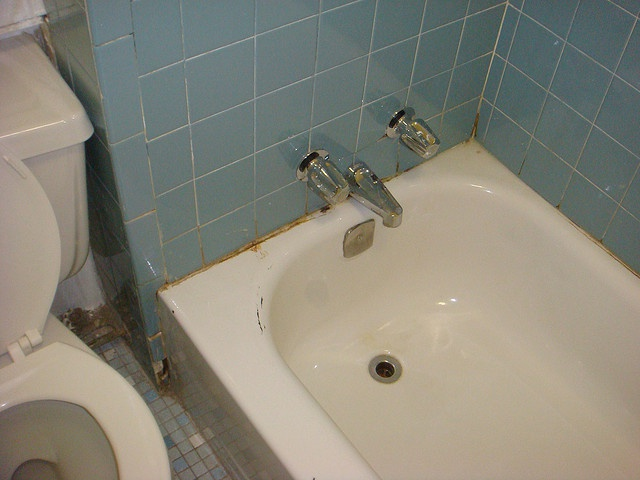Describe the objects in this image and their specific colors. I can see a toilet in gray, darkgray, and tan tones in this image. 